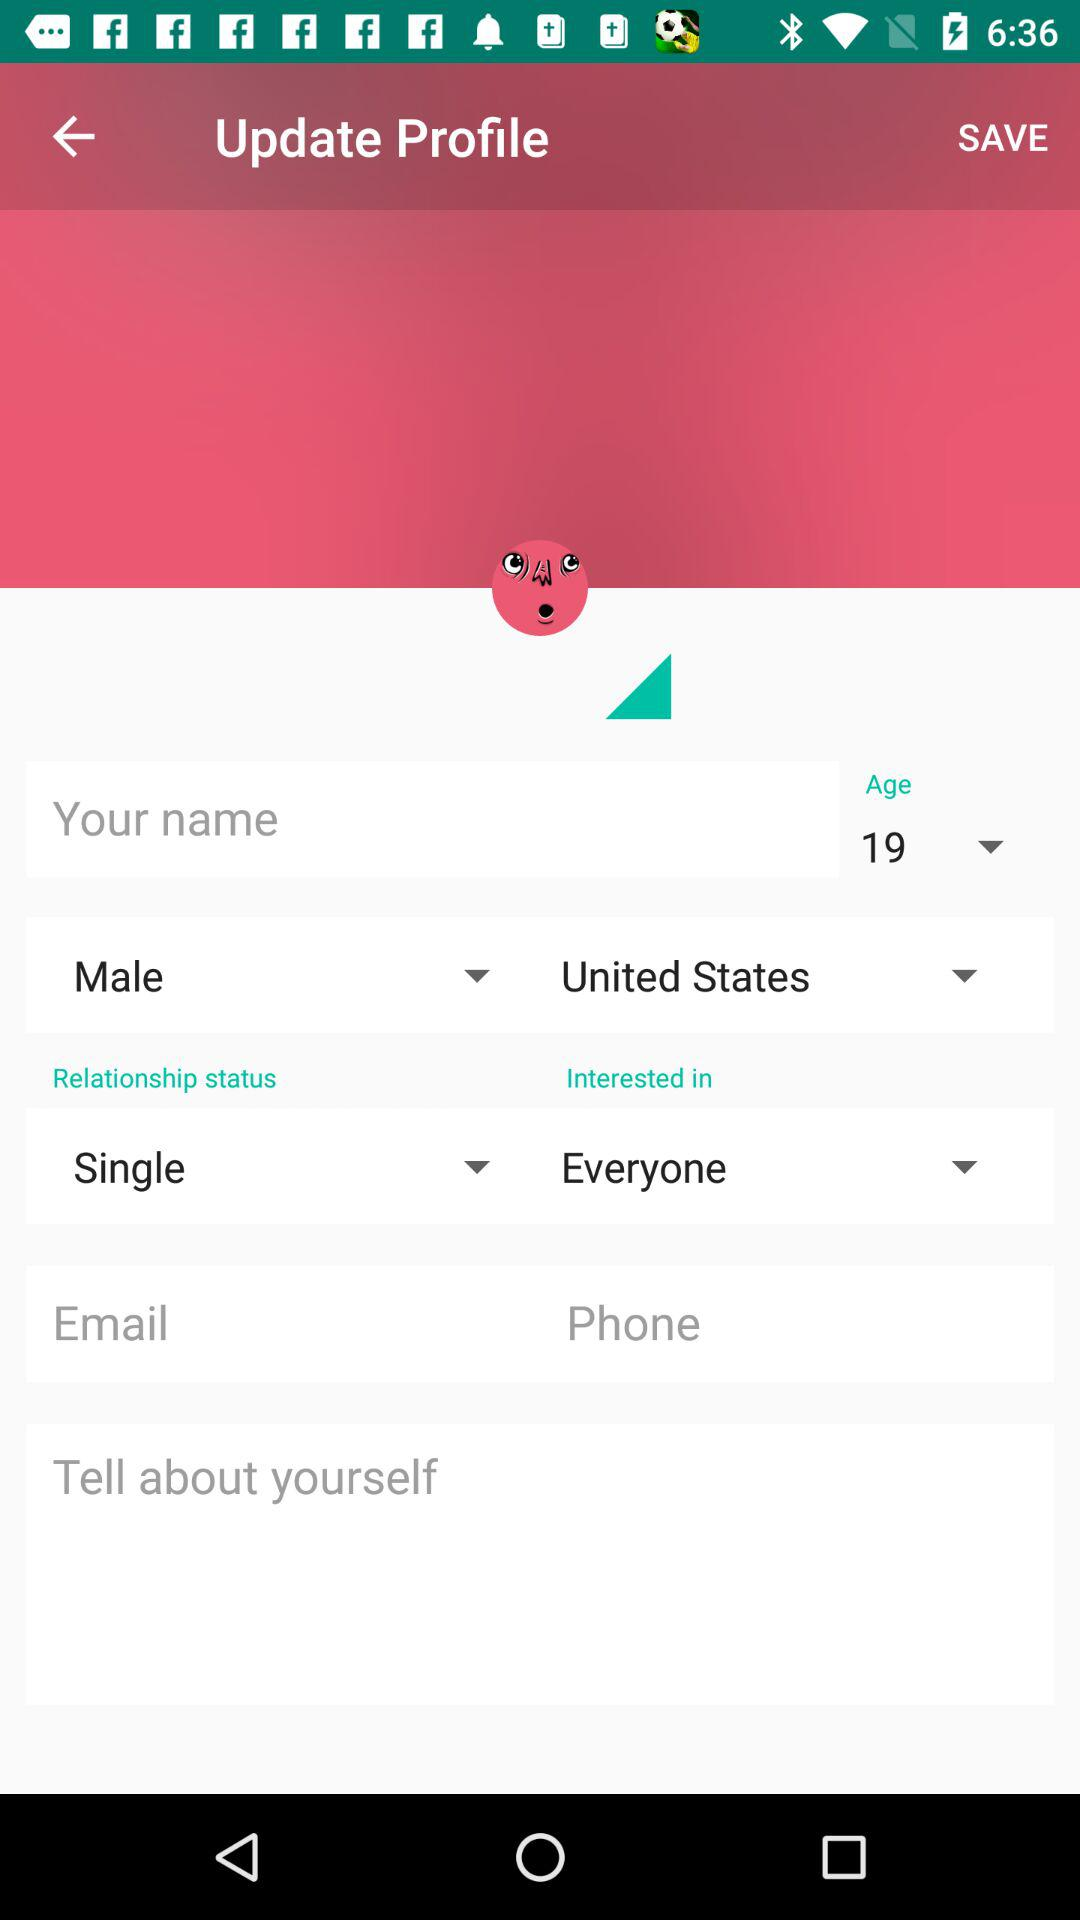What is the age of the user? The age of the user is 19. 